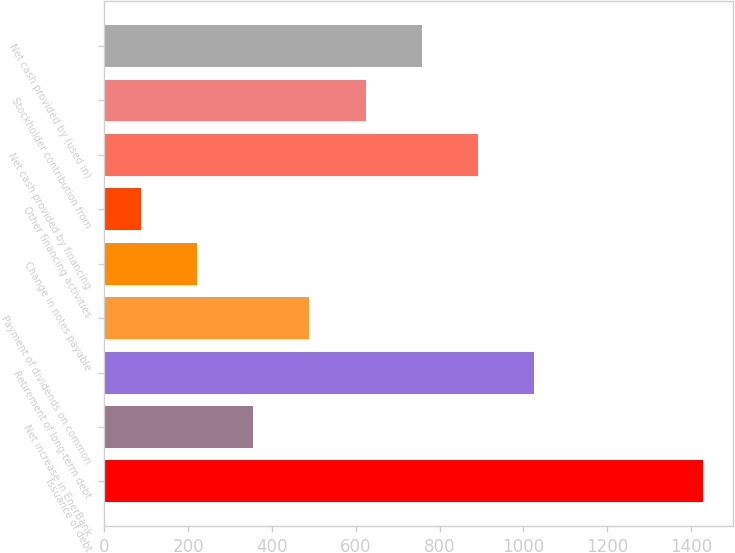Convert chart to OTSL. <chart><loc_0><loc_0><loc_500><loc_500><bar_chart><fcel>Issuance of debt<fcel>Net increase in EnerBank<fcel>Retirement of long-term debt<fcel>Payment of dividends on common<fcel>Change in notes payable<fcel>Other financing activities<fcel>Net cash provided by financing<fcel>Stockholder contribution from<fcel>Net cash provided by (used in)<nl><fcel>1428<fcel>355.2<fcel>1025.7<fcel>489.3<fcel>221.1<fcel>87<fcel>891.6<fcel>623.4<fcel>757.5<nl></chart> 